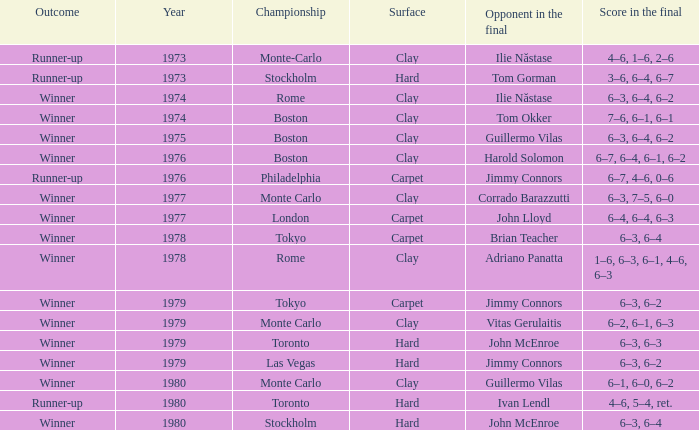Name the year for clay for boston and guillermo vilas 1975.0. 